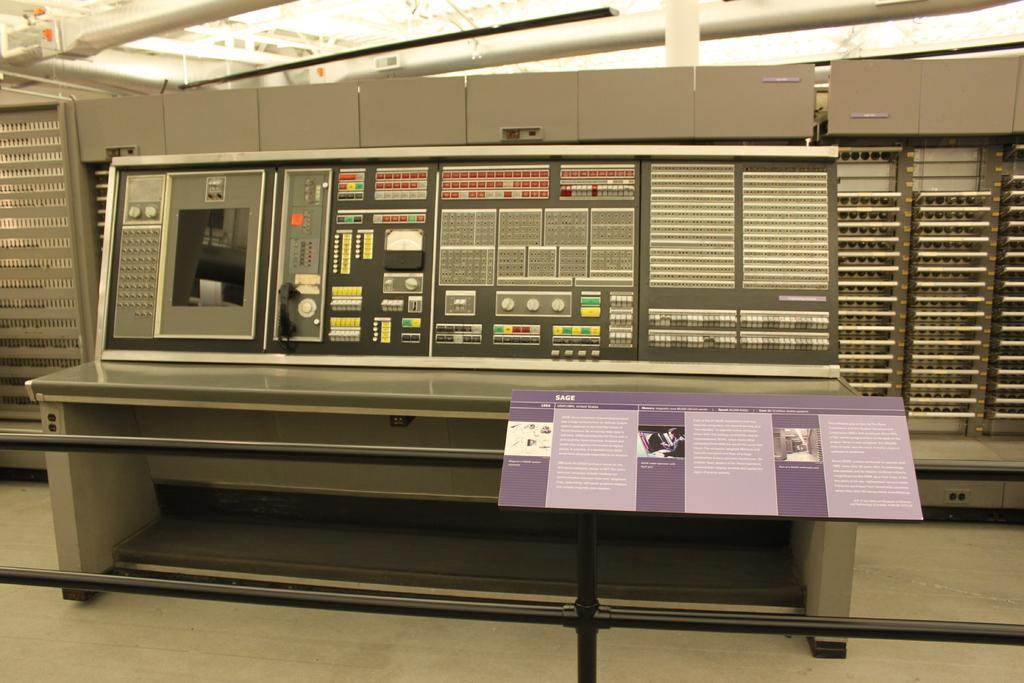Please provide a concise description of this image. In this image I can see a control board which is in gray and black color. I can also see few buttons in multi color, in front I can see a board which is in purple color attached to the pole. 